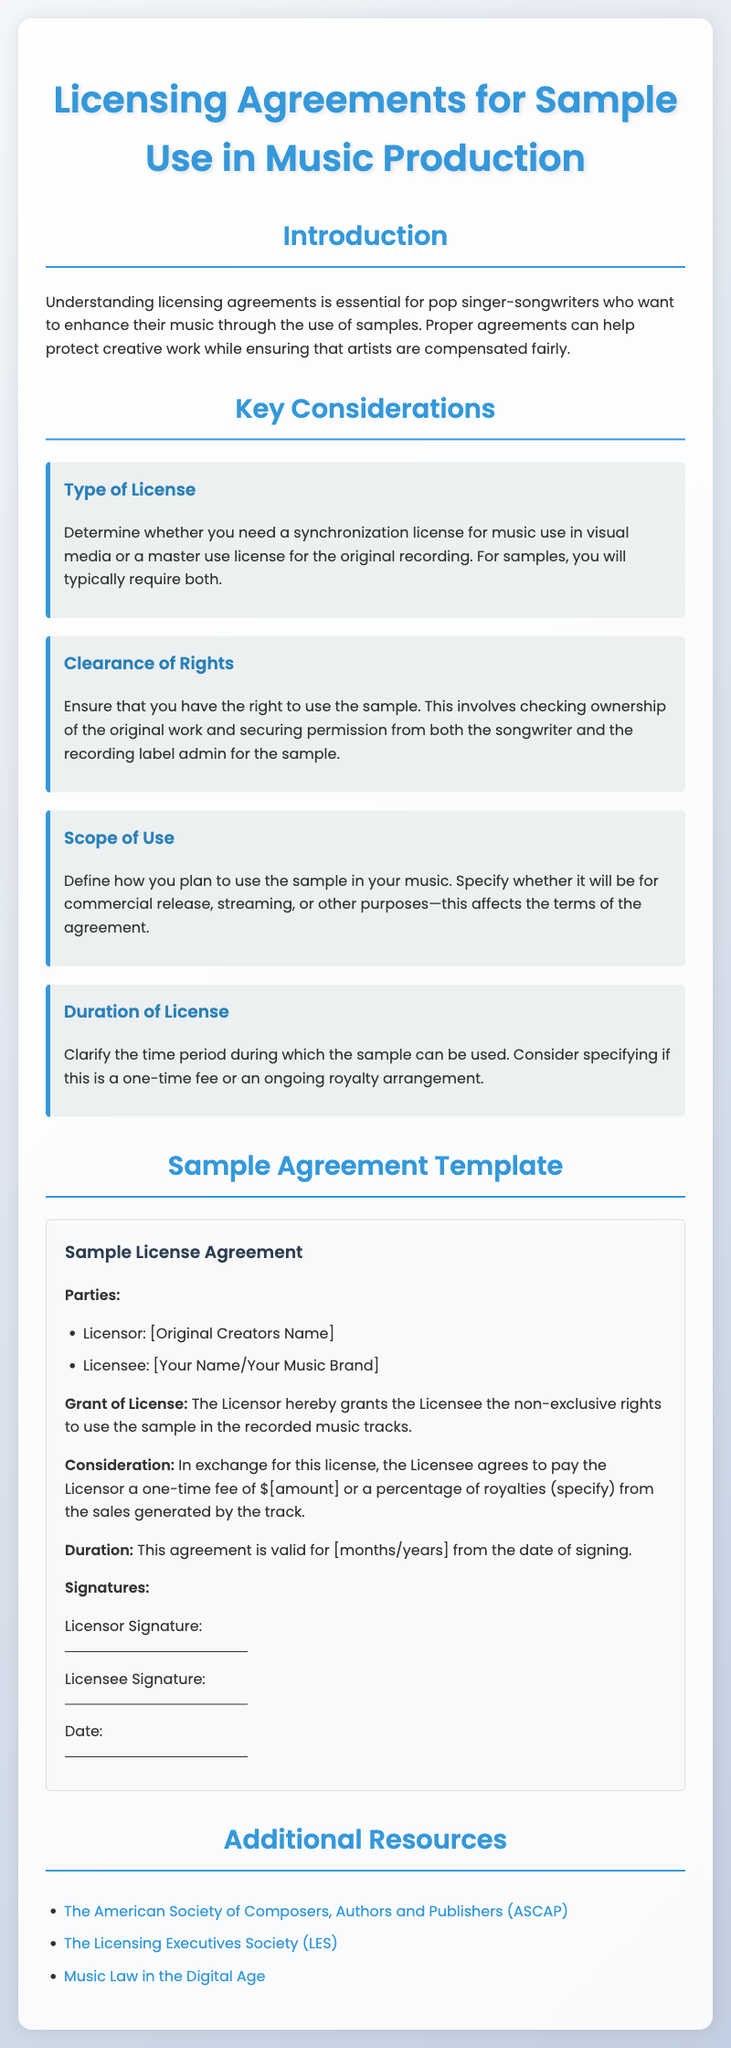What is the purpose of licensing agreements? The purpose is to enhance music through the use of samples, while protecting creative work and ensuring fair compensation for artists.
Answer: Enhance music through samples What type of license do you need for a sample? You typically require both a synchronization license for music use in visual media and a master use license for the original recording.
Answer: Synchronization and master use license What must you check before using a sample? You must check ownership of the original work and secure permission from both the songwriter and the recording label admin.
Answer: Ownership and permission What is the duration option for a license? The document suggests specifying if the license is a one-time fee or an ongoing royalty arrangement.
Answer: One-time fee or ongoing royalty What is the title of the document? The title is provided at the start of the document, indicating the crucial topic covered.
Answer: Licensing Agreements for Sample Use in Music Production What does the Licensor grant the Licensee? The Licensor grants the Licensee non-exclusive rights to use the sample in recorded music tracks.
Answer: Non-exclusive rights to use the sample What type of agreement is provided in the document? The document includes a sample license agreement template that can be used by musicians.
Answer: Sample License Agreement What is included in the list of additional resources? The document lists organizations such as ASCAP and the Licensing Executives Society for further support.
Answer: ASCAP and Licensing Executives Society What is the fee arrangement mentioned in the sample agreement? The fee arrangement may include a one-time fee or a percentage of royalties from sales generated by the track.
Answer: One-time fee or percentage of royalties 